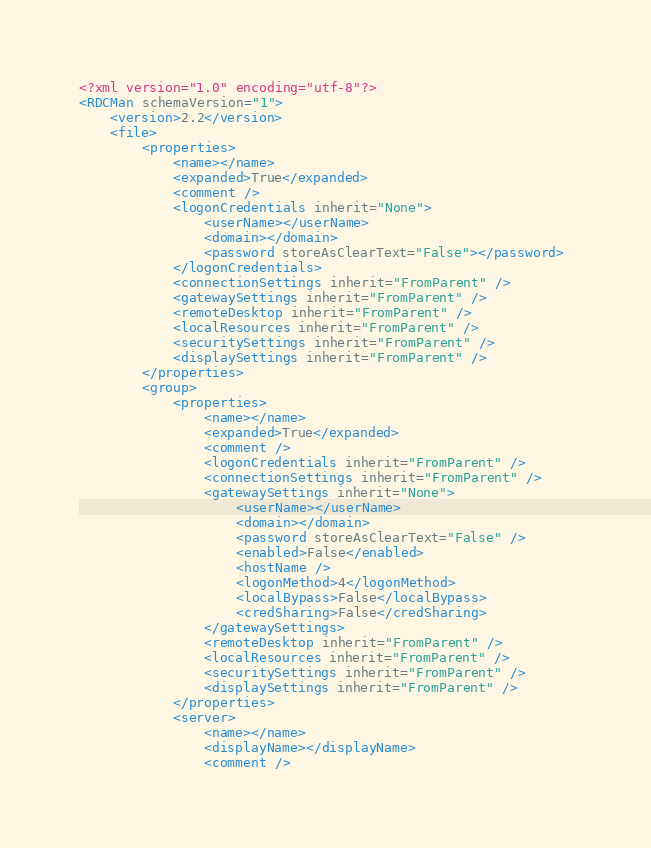<code> <loc_0><loc_0><loc_500><loc_500><_XML_><?xml version="1.0" encoding="utf-8"?> 
<RDCMan schemaVersion="1"> 
    <version>2.2</version> 
    <file> 
        <properties> 
            <name></name> 
            <expanded>True</expanded> 
            <comment /> 
            <logonCredentials inherit="None"> 
                <userName></userName> 
                <domain></domain> 
                <password storeAsClearText="False"></password> 
            </logonCredentials> 
            <connectionSettings inherit="FromParent" /> 
            <gatewaySettings inherit="FromParent" /> 
            <remoteDesktop inherit="FromParent" /> 
            <localResources inherit="FromParent" /> 
            <securitySettings inherit="FromParent" /> 
            <displaySettings inherit="FromParent" /> 
        </properties> 
		<group> 
            <properties> 
                <name></name> 
                <expanded>True</expanded> 
                <comment /> 
                <logonCredentials inherit="FromParent" /> 
                <connectionSettings inherit="FromParent" /> 
                <gatewaySettings inherit="None"> 
                    <userName></userName> 
                    <domain></domain> 
                    <password storeAsClearText="False" /> 
                    <enabled>False</enabled> 
                    <hostName /> 
                    <logonMethod>4</logonMethod> 
                    <localBypass>False</localBypass> 
                    <credSharing>False</credSharing> 
                </gatewaySettings> 
                <remoteDesktop inherit="FromParent" /> 
                <localResources inherit="FromParent" /> 
                <securitySettings inherit="FromParent" /> 
                <displaySettings inherit="FromParent" /> 
            </properties> 
            <server> 
                <name></name> 
                <displayName></displayName> 
                <comment /> </code> 